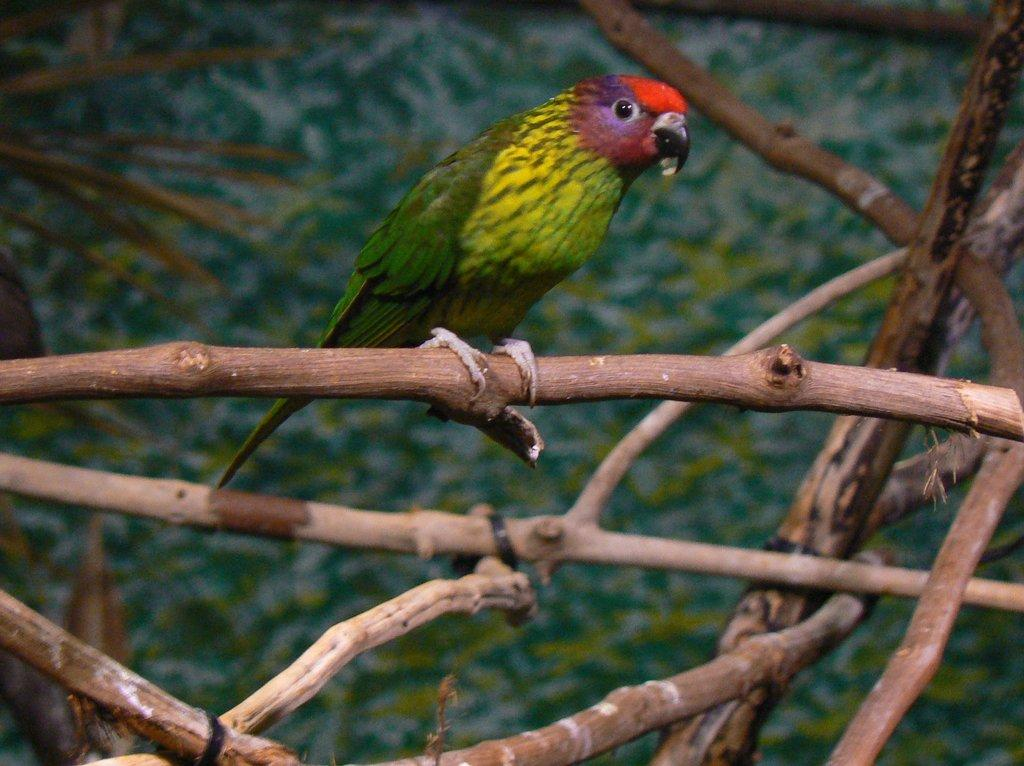What type of animal is in the image? There is a parrot in the image. Where is the parrot located? The parrot is on a tree. What is the weight of the church in the image? There is no church present in the image, so it is not possible to determine its weight. 